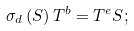<formula> <loc_0><loc_0><loc_500><loc_500>\sigma _ { d } \left ( S \right ) T ^ { b } = T ^ { e } S ;</formula> 